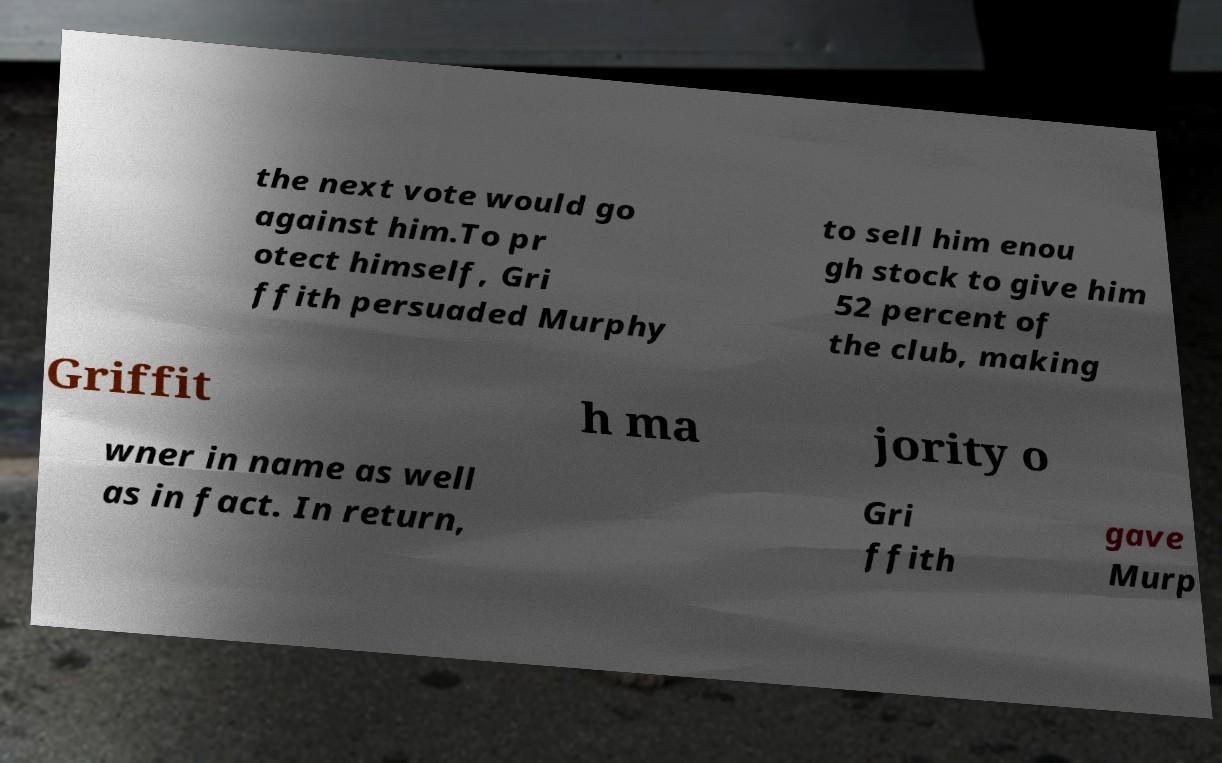Please read and relay the text visible in this image. What does it say? the next vote would go against him.To pr otect himself, Gri ffith persuaded Murphy to sell him enou gh stock to give him 52 percent of the club, making Griffit h ma jority o wner in name as well as in fact. In return, Gri ffith gave Murp 